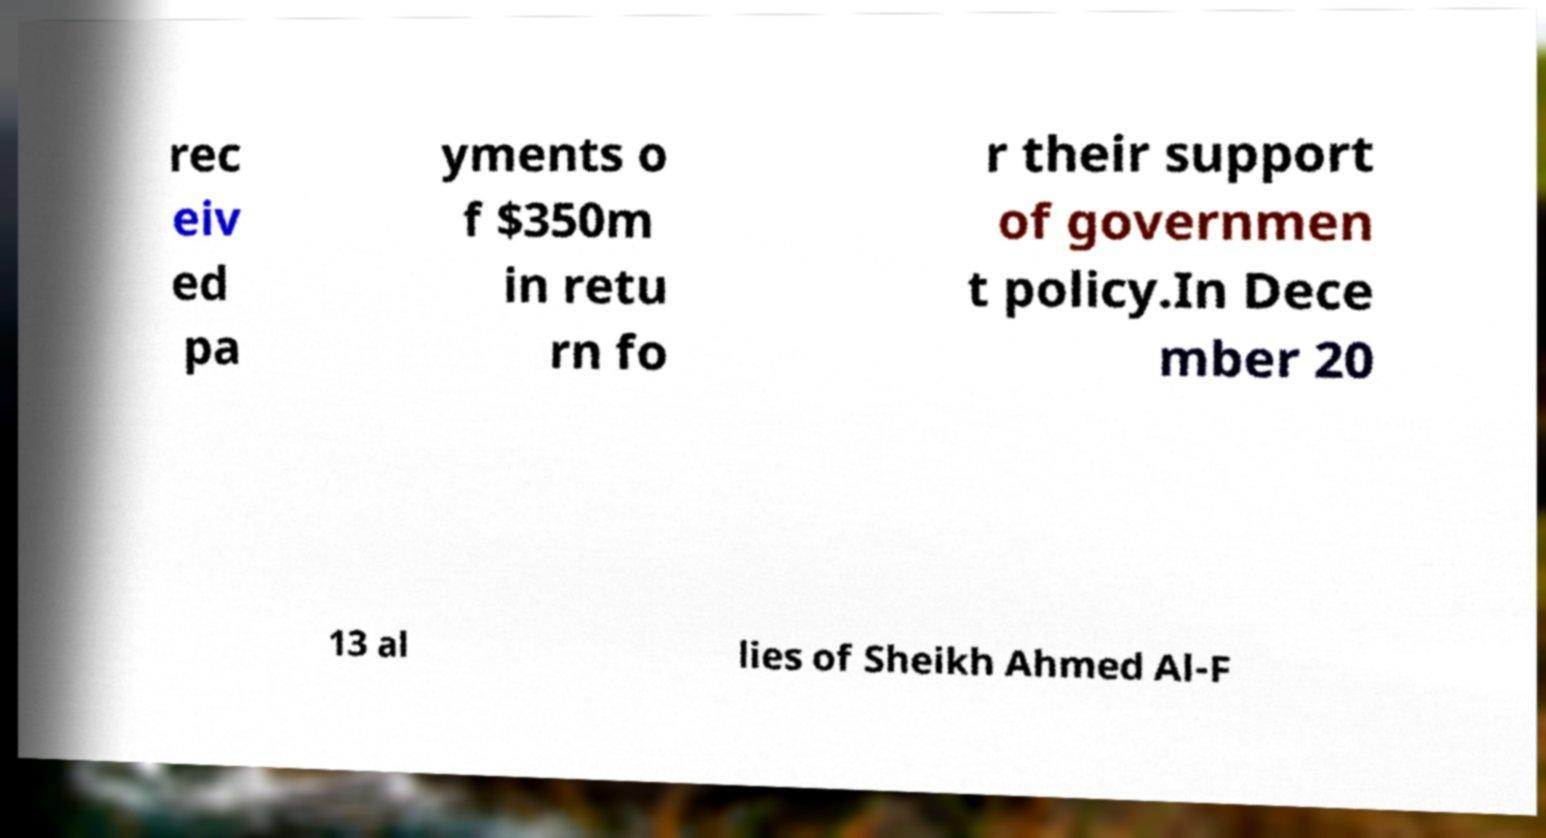What messages or text are displayed in this image? I need them in a readable, typed format. rec eiv ed pa yments o f $350m in retu rn fo r their support of governmen t policy.In Dece mber 20 13 al lies of Sheikh Ahmed Al-F 